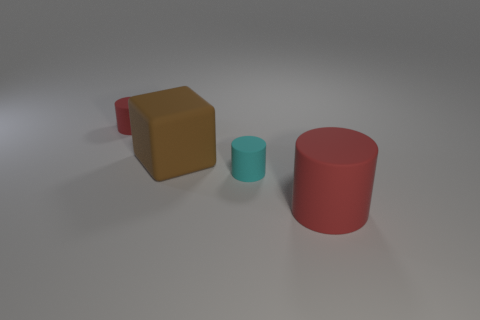Subtract all red cylinders. How many were subtracted if there are1red cylinders left? 1 Subtract all red matte cylinders. How many cylinders are left? 1 Subtract all red cylinders. How many cylinders are left? 1 Subtract all yellow blocks. How many red cylinders are left? 2 Add 4 cyan matte cylinders. How many objects exist? 8 Subtract all blocks. How many objects are left? 3 Subtract 1 cubes. How many cubes are left? 0 Add 3 cyan cylinders. How many cyan cylinders are left? 4 Add 2 big blue metallic blocks. How many big blue metallic blocks exist? 2 Subtract 0 green cylinders. How many objects are left? 4 